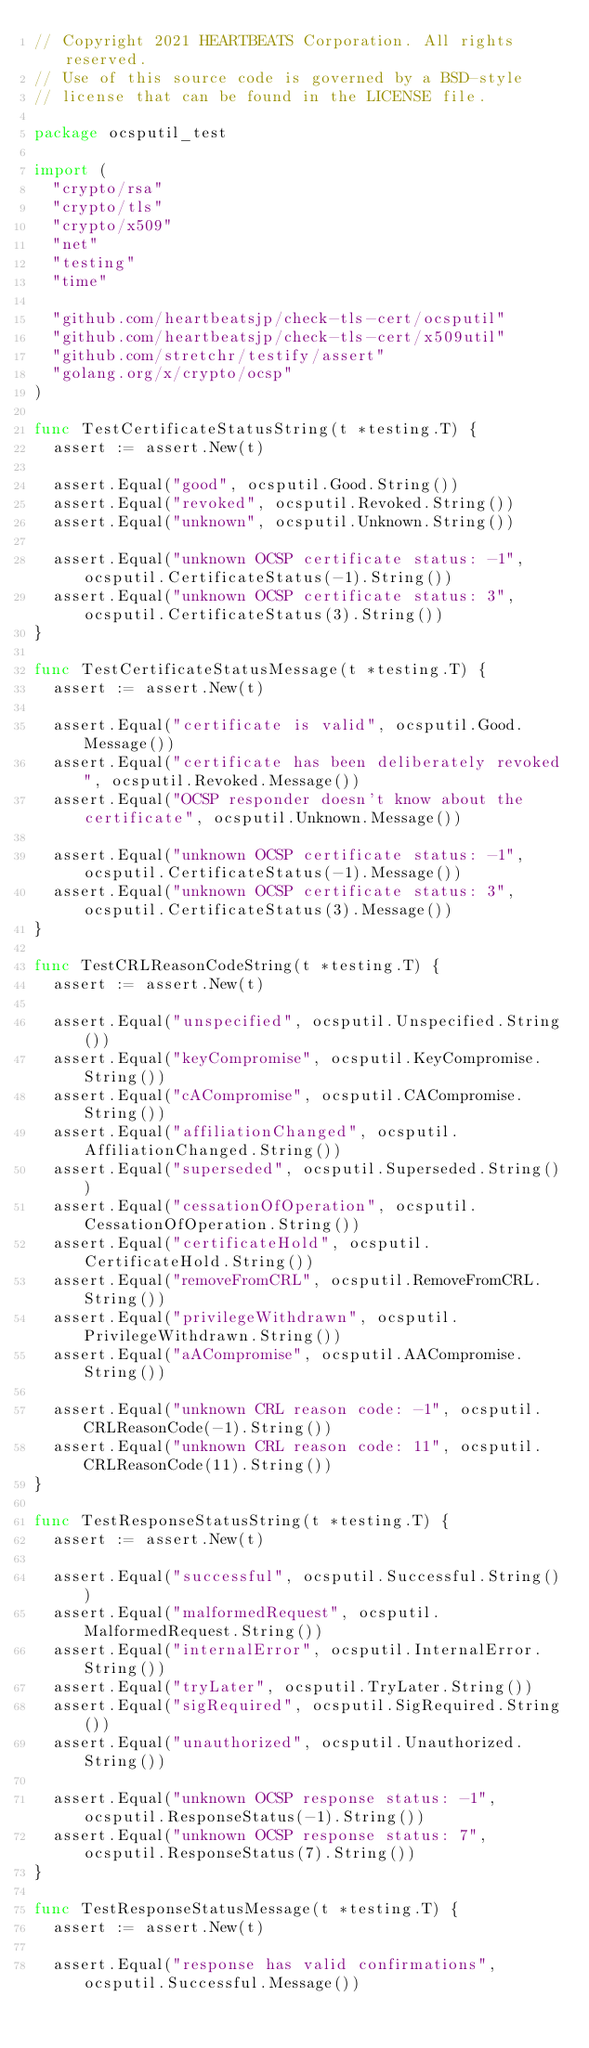Convert code to text. <code><loc_0><loc_0><loc_500><loc_500><_Go_>// Copyright 2021 HEARTBEATS Corporation. All rights reserved.
// Use of this source code is governed by a BSD-style
// license that can be found in the LICENSE file.

package ocsputil_test

import (
	"crypto/rsa"
	"crypto/tls"
	"crypto/x509"
	"net"
	"testing"
	"time"

	"github.com/heartbeatsjp/check-tls-cert/ocsputil"
	"github.com/heartbeatsjp/check-tls-cert/x509util"
	"github.com/stretchr/testify/assert"
	"golang.org/x/crypto/ocsp"
)

func TestCertificateStatusString(t *testing.T) {
	assert := assert.New(t)

	assert.Equal("good", ocsputil.Good.String())
	assert.Equal("revoked", ocsputil.Revoked.String())
	assert.Equal("unknown", ocsputil.Unknown.String())

	assert.Equal("unknown OCSP certificate status: -1", ocsputil.CertificateStatus(-1).String())
	assert.Equal("unknown OCSP certificate status: 3", ocsputil.CertificateStatus(3).String())
}

func TestCertificateStatusMessage(t *testing.T) {
	assert := assert.New(t)

	assert.Equal("certificate is valid", ocsputil.Good.Message())
	assert.Equal("certificate has been deliberately revoked", ocsputil.Revoked.Message())
	assert.Equal("OCSP responder doesn't know about the certificate", ocsputil.Unknown.Message())

	assert.Equal("unknown OCSP certificate status: -1", ocsputil.CertificateStatus(-1).Message())
	assert.Equal("unknown OCSP certificate status: 3", ocsputil.CertificateStatus(3).Message())
}

func TestCRLReasonCodeString(t *testing.T) {
	assert := assert.New(t)

	assert.Equal("unspecified", ocsputil.Unspecified.String())
	assert.Equal("keyCompromise", ocsputil.KeyCompromise.String())
	assert.Equal("cACompromise", ocsputil.CACompromise.String())
	assert.Equal("affiliationChanged", ocsputil.AffiliationChanged.String())
	assert.Equal("superseded", ocsputil.Superseded.String())
	assert.Equal("cessationOfOperation", ocsputil.CessationOfOperation.String())
	assert.Equal("certificateHold", ocsputil.CertificateHold.String())
	assert.Equal("removeFromCRL", ocsputil.RemoveFromCRL.String())
	assert.Equal("privilegeWithdrawn", ocsputil.PrivilegeWithdrawn.String())
	assert.Equal("aACompromise", ocsputil.AACompromise.String())

	assert.Equal("unknown CRL reason code: -1", ocsputil.CRLReasonCode(-1).String())
	assert.Equal("unknown CRL reason code: 11", ocsputil.CRLReasonCode(11).String())
}

func TestResponseStatusString(t *testing.T) {
	assert := assert.New(t)

	assert.Equal("successful", ocsputil.Successful.String())
	assert.Equal("malformedRequest", ocsputil.MalformedRequest.String())
	assert.Equal("internalError", ocsputil.InternalError.String())
	assert.Equal("tryLater", ocsputil.TryLater.String())
	assert.Equal("sigRequired", ocsputil.SigRequired.String())
	assert.Equal("unauthorized", ocsputil.Unauthorized.String())

	assert.Equal("unknown OCSP response status: -1", ocsputil.ResponseStatus(-1).String())
	assert.Equal("unknown OCSP response status: 7", ocsputil.ResponseStatus(7).String())
}

func TestResponseStatusMessage(t *testing.T) {
	assert := assert.New(t)

	assert.Equal("response has valid confirmations", ocsputil.Successful.Message())</code> 